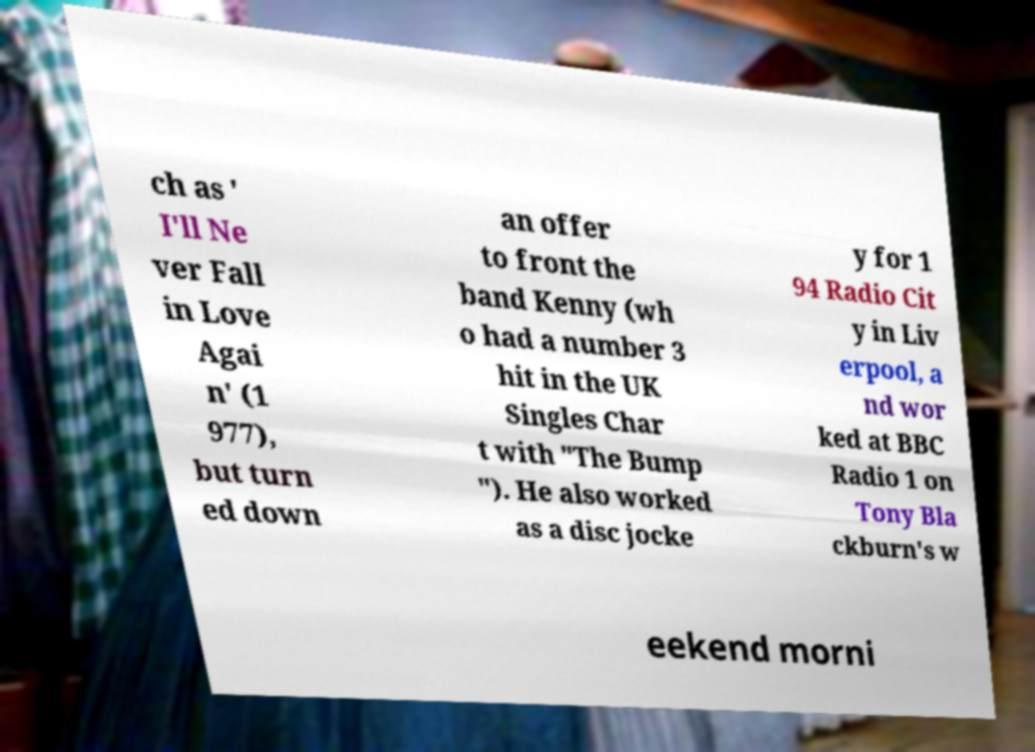Please identify and transcribe the text found in this image. ch as ' I'll Ne ver Fall in Love Agai n' (1 977), but turn ed down an offer to front the band Kenny (wh o had a number 3 hit in the UK Singles Char t with "The Bump "). He also worked as a disc jocke y for 1 94 Radio Cit y in Liv erpool, a nd wor ked at BBC Radio 1 on Tony Bla ckburn's w eekend morni 